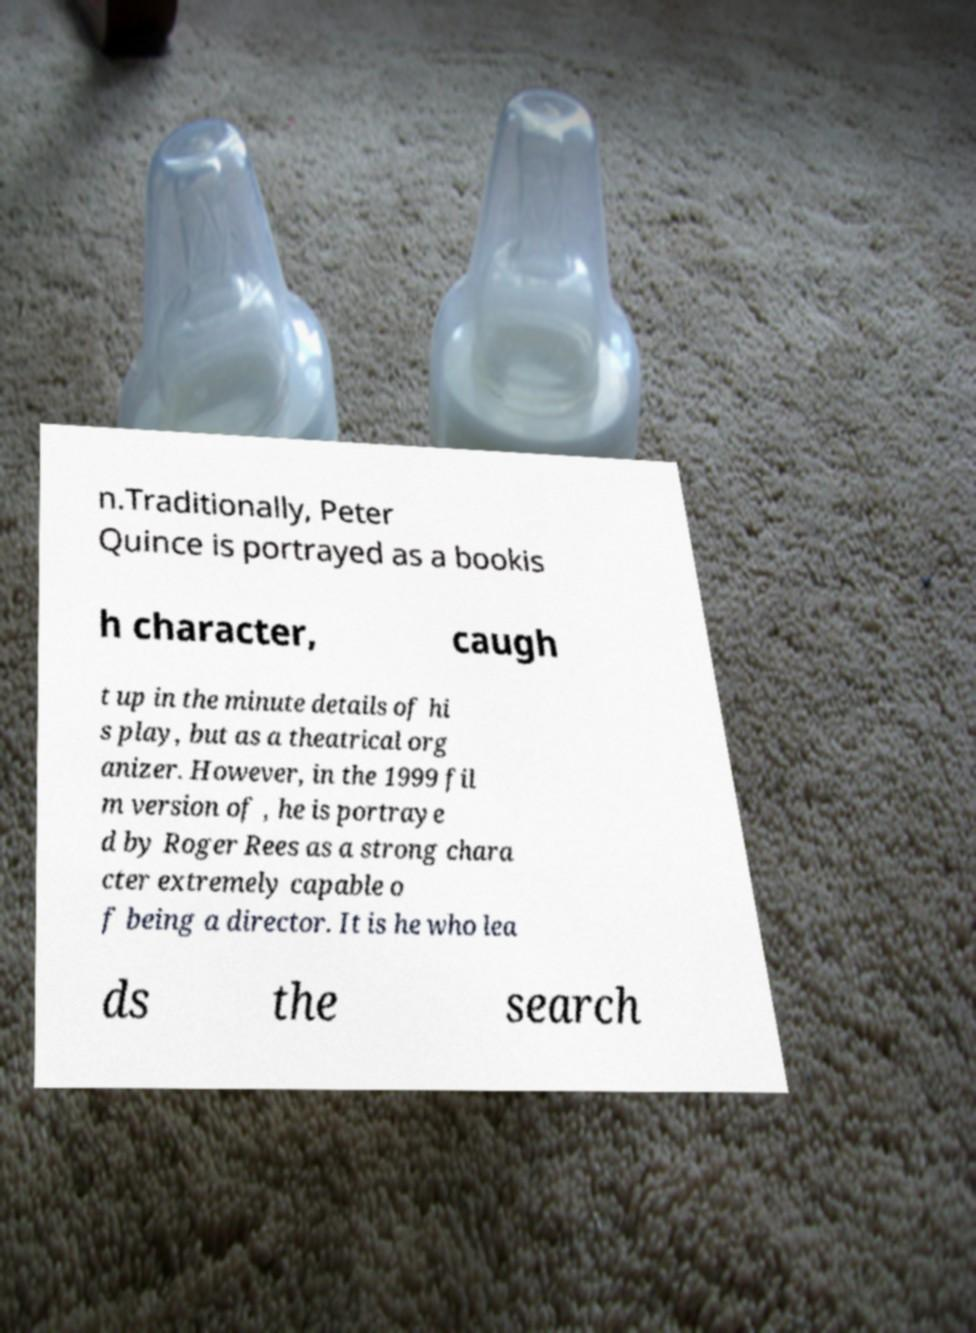For documentation purposes, I need the text within this image transcribed. Could you provide that? n.Traditionally, Peter Quince is portrayed as a bookis h character, caugh t up in the minute details of hi s play, but as a theatrical org anizer. However, in the 1999 fil m version of , he is portraye d by Roger Rees as a strong chara cter extremely capable o f being a director. It is he who lea ds the search 